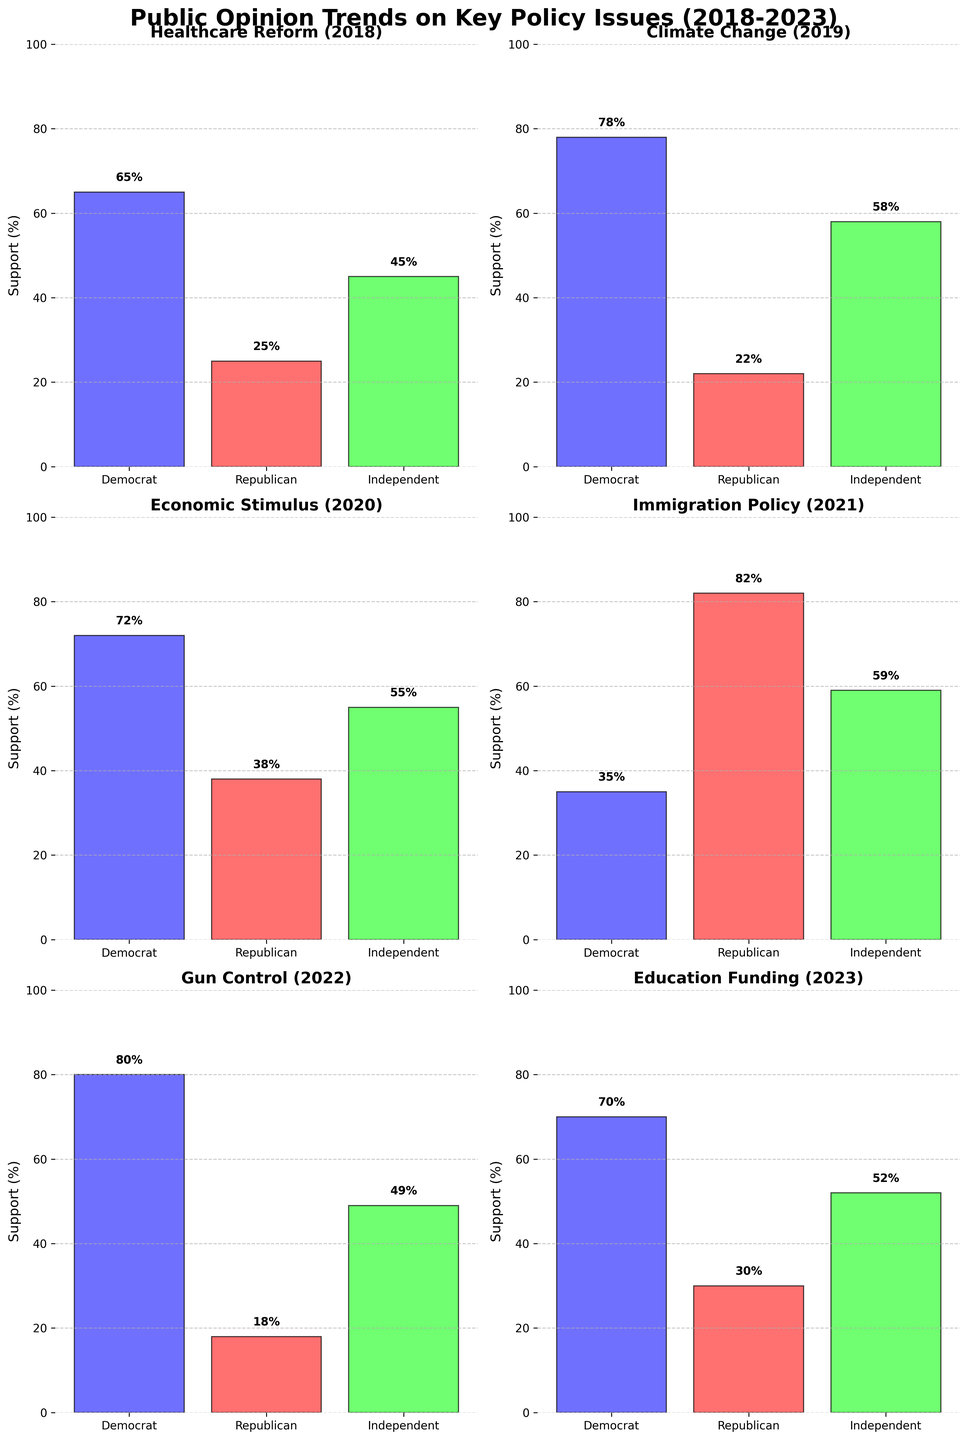What's the highest level of support among Democrats? The figure shows multiple bar charts for different policy issues, segmented by political affiliation. The heights of the bars represent the support levels. We look for the tallest blue bar (Democrats) across all subplots. The highest level is for "Gun Control" in 2022 which is 80%.
Answer: 80% Which issue had the greatest difference in support between Democrats and Republicans? To find the greatest difference, we compare the support levels of Democrats and Republicans for each issue. We calculate the absolute difference for each: Healthcare Reform (40%), Climate Change (56%), Economic Stimulus (34%), Immigration Policy (47%), Gun Control (62%), Education Funding (40%). The largest difference is for Gun Control in 2022 with a difference of 62%.
Answer: Gun Control (62%) What is the average support for Healthcare Reform in 2018 across all affiliations? Sum the support for Healthcare Reform across Democrats (65), Republicans (25), and Independents (45). Then divide by 3 to get the average. (65 + 25 + 45) / 3 = 45%
Answer: 45% For which issue do Independents have the closest support level to Democrats? To determine this, we look at the differences in support between Independents and Democrats for each issue: Healthcare Reform (20%), Climate Change (20%), Economic Stimulus (17%), Immigration Policy (24%), Gun Control (31%), Education Funding (18%). The closest support level is for Economic Stimulus in 2020 with a difference of 17%.
Answer: Economic Stimulus (17%) What is the overall trend of support among Republicans for the issues over the years? We observe the heights of the red bars representing Republican support across the years from 2018 to 2023. The trend alternates but generally stays low with no clear upward or downward pattern. Specific years: 25% (2018), 22% (2019), 38% (2020), 82% (2021), 18% (2022), 30% (2023).
Answer: No clear trend Which year showed the highest variance in support levels among the three affiliations for any issue? Calculate the variance in support levels for each issue/year: Healthcare Reform (2018), Climate Change (2019), Economic Stimulus (2020), Immigration Policy (2021), Gun Control (2022), Education Funding (2023). The year with the highest range (difference between maximum and minimum support) is Immigration Policy 2021 where Democrat (35%) and Republican (82%) show the highest range of variance of 47%.
Answer: 2021 (47%) 